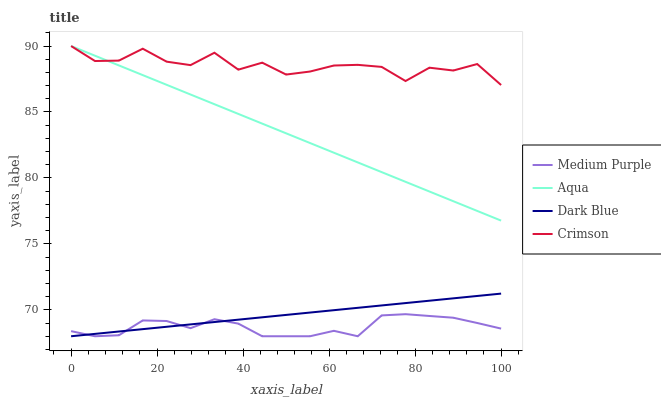Does Medium Purple have the minimum area under the curve?
Answer yes or no. Yes. Does Crimson have the maximum area under the curve?
Answer yes or no. Yes. Does Dark Blue have the minimum area under the curve?
Answer yes or no. No. Does Dark Blue have the maximum area under the curve?
Answer yes or no. No. Is Dark Blue the smoothest?
Answer yes or no. Yes. Is Crimson the roughest?
Answer yes or no. Yes. Is Aqua the smoothest?
Answer yes or no. No. Is Aqua the roughest?
Answer yes or no. No. Does Medium Purple have the lowest value?
Answer yes or no. Yes. Does Aqua have the lowest value?
Answer yes or no. No. Does Crimson have the highest value?
Answer yes or no. Yes. Does Dark Blue have the highest value?
Answer yes or no. No. Is Dark Blue less than Aqua?
Answer yes or no. Yes. Is Crimson greater than Dark Blue?
Answer yes or no. Yes. Does Aqua intersect Crimson?
Answer yes or no. Yes. Is Aqua less than Crimson?
Answer yes or no. No. Is Aqua greater than Crimson?
Answer yes or no. No. Does Dark Blue intersect Aqua?
Answer yes or no. No. 